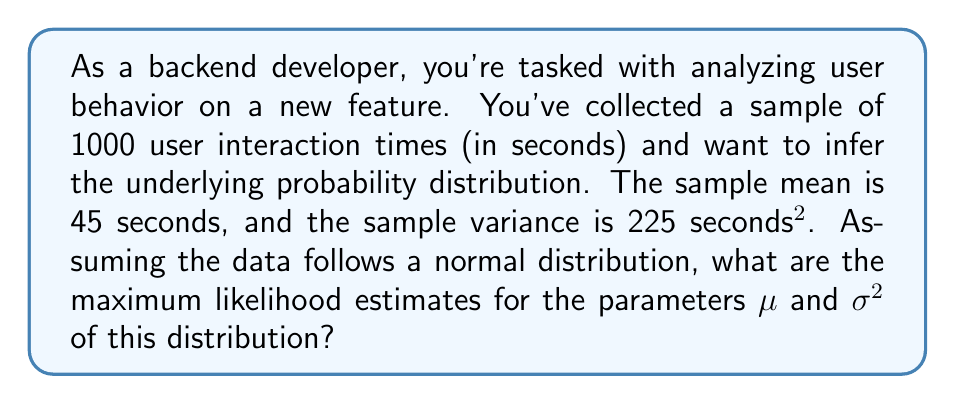Provide a solution to this math problem. To infer the underlying probability distribution from observed samples, we can use the method of maximum likelihood estimation (MLE). For a normal distribution, the MLE estimates for the mean ($\mu$) and variance ($\sigma^2$) are the sample mean and sample variance, respectively.

Given:
- Sample size: $n = 1000$
- Sample mean: $\bar{x} = 45$ seconds
- Sample variance: $s^2 = 225$ seconds²

Step 1: Estimate $\mu$
The MLE for $\mu$ is the sample mean:
$$\hat{\mu} = \bar{x} = 45$$

Step 2: Estimate $\sigma^2$
The MLE for $\sigma^2$ is the sample variance:
$$\hat{\sigma}^2 = s^2 = 225$$

Therefore, the maximum likelihood estimates for the parameters of the normal distribution are:
$\mu = 45$ seconds
$\sigma^2 = 225$ seconds²

This means that the inferred probability distribution is a normal distribution with these parameters, which can be written as:
$$X \sim N(45, 225)$$

where $X$ represents the user interaction time in seconds.
Answer: $\mu = 45$, $\sigma^2 = 225$ 